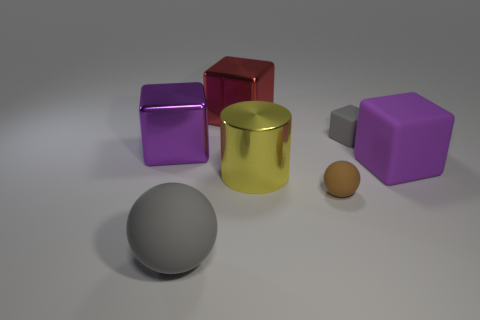Subtract all tiny gray cubes. How many cubes are left? 3 Subtract all gray cubes. How many cubes are left? 3 Subtract 1 blocks. How many blocks are left? 3 Subtract all yellow blocks. Subtract all purple balls. How many blocks are left? 4 Add 2 yellow rubber cylinders. How many objects exist? 9 Subtract all balls. How many objects are left? 5 Subtract 0 blue cylinders. How many objects are left? 7 Subtract all purple blocks. Subtract all big purple metal blocks. How many objects are left? 4 Add 2 shiny cylinders. How many shiny cylinders are left? 3 Add 1 large yellow spheres. How many large yellow spheres exist? 1 